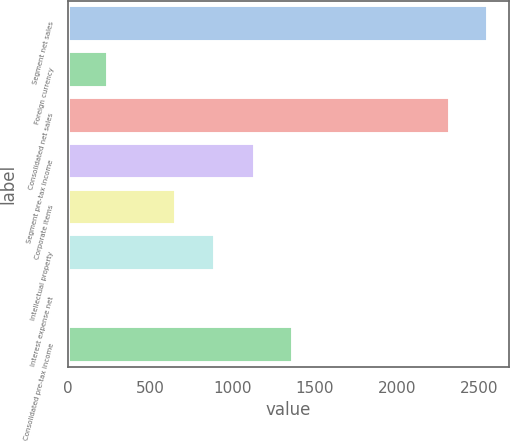<chart> <loc_0><loc_0><loc_500><loc_500><bar_chart><fcel>Segment net sales<fcel>Foreign currency<fcel>Consolidated net sales<fcel>Segment pre-tax income<fcel>Corporate items<fcel>Intellectual property<fcel>Interest expense net<fcel>Consolidated pre-tax income<nl><fcel>2556.28<fcel>244.18<fcel>2322.9<fcel>1137.5<fcel>659.2<fcel>892.58<fcel>10.8<fcel>1370.88<nl></chart> 